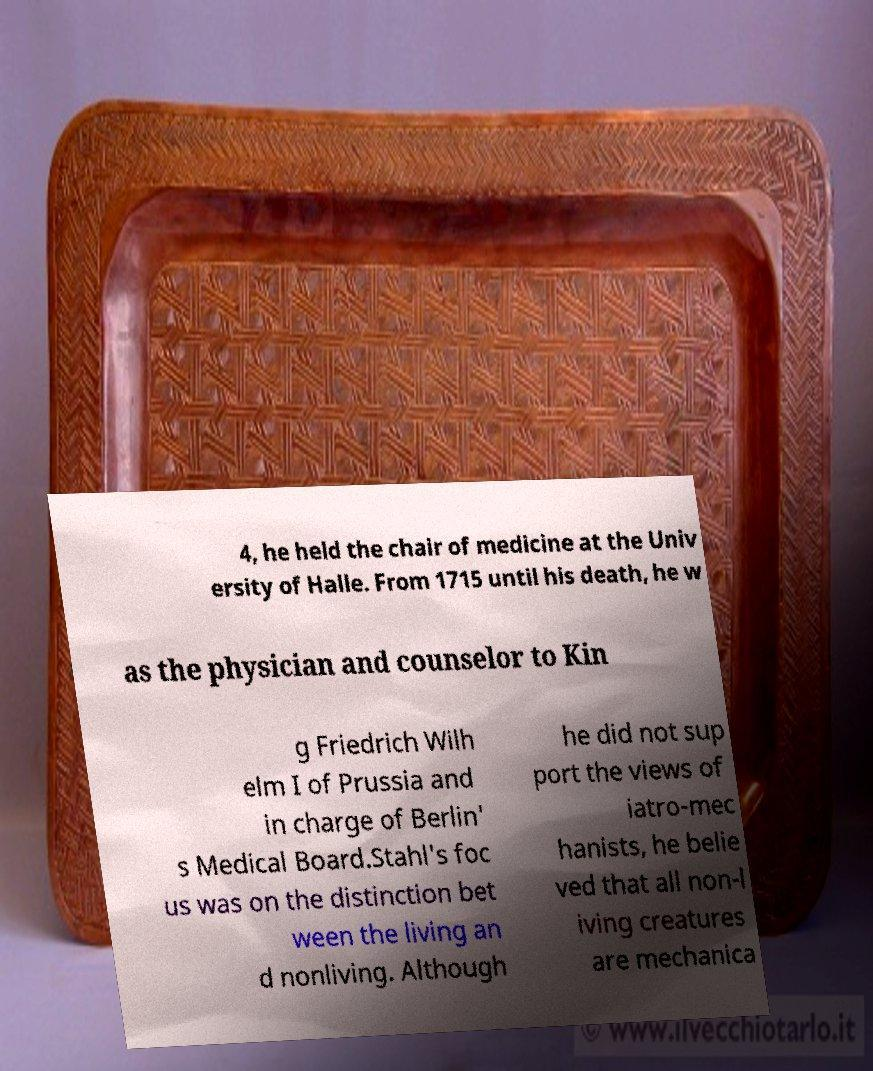Could you extract and type out the text from this image? 4, he held the chair of medicine at the Univ ersity of Halle. From 1715 until his death, he w as the physician and counselor to Kin g Friedrich Wilh elm I of Prussia and in charge of Berlin' s Medical Board.Stahl's foc us was on the distinction bet ween the living an d nonliving. Although he did not sup port the views of iatro-mec hanists, he belie ved that all non-l iving creatures are mechanica 